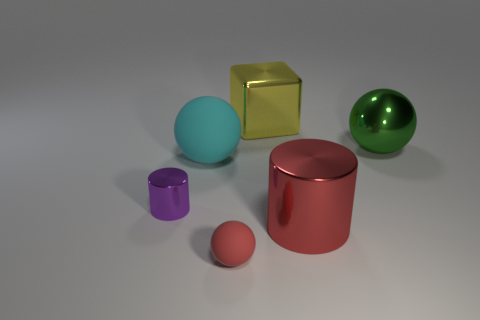Subtract all small red rubber spheres. How many spheres are left? 2 Add 3 red rubber spheres. How many objects exist? 9 Subtract all blocks. How many objects are left? 5 Subtract all green balls. How many balls are left? 2 Subtract all cyan spheres. How many red cylinders are left? 1 Add 3 small rubber objects. How many small rubber objects are left? 4 Add 5 small yellow matte cubes. How many small yellow matte cubes exist? 5 Subtract 0 blue cylinders. How many objects are left? 6 Subtract all purple cubes. Subtract all yellow cylinders. How many cubes are left? 1 Subtract all small objects. Subtract all large green spheres. How many objects are left? 3 